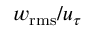<formula> <loc_0><loc_0><loc_500><loc_500>w _ { r m s } / u _ { \tau }</formula> 